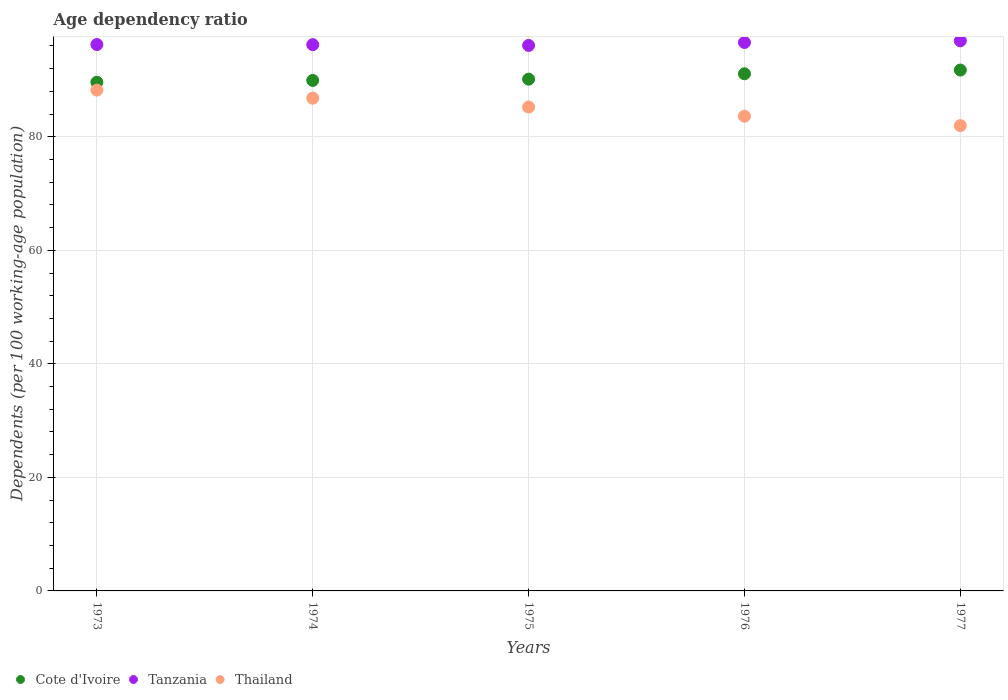How many different coloured dotlines are there?
Offer a very short reply. 3. Is the number of dotlines equal to the number of legend labels?
Your answer should be very brief. Yes. What is the age dependency ratio in in Tanzania in 1977?
Give a very brief answer. 96.91. Across all years, what is the maximum age dependency ratio in in Cote d'Ivoire?
Make the answer very short. 91.76. Across all years, what is the minimum age dependency ratio in in Tanzania?
Your answer should be very brief. 96.09. In which year was the age dependency ratio in in Tanzania minimum?
Offer a very short reply. 1975. What is the total age dependency ratio in in Thailand in the graph?
Your response must be concise. 425.87. What is the difference between the age dependency ratio in in Cote d'Ivoire in 1974 and that in 1976?
Make the answer very short. -1.17. What is the difference between the age dependency ratio in in Tanzania in 1973 and the age dependency ratio in in Cote d'Ivoire in 1975?
Your answer should be compact. 6.1. What is the average age dependency ratio in in Cote d'Ivoire per year?
Your response must be concise. 90.51. In the year 1974, what is the difference between the age dependency ratio in in Tanzania and age dependency ratio in in Thailand?
Your answer should be very brief. 9.42. In how many years, is the age dependency ratio in in Cote d'Ivoire greater than 28 %?
Your response must be concise. 5. What is the ratio of the age dependency ratio in in Tanzania in 1974 to that in 1976?
Your answer should be compact. 1. Is the age dependency ratio in in Thailand in 1975 less than that in 1976?
Provide a short and direct response. No. Is the difference between the age dependency ratio in in Tanzania in 1974 and 1976 greater than the difference between the age dependency ratio in in Thailand in 1974 and 1976?
Provide a short and direct response. No. What is the difference between the highest and the second highest age dependency ratio in in Thailand?
Give a very brief answer. 1.42. What is the difference between the highest and the lowest age dependency ratio in in Cote d'Ivoire?
Give a very brief answer. 2.14. Is the sum of the age dependency ratio in in Cote d'Ivoire in 1973 and 1977 greater than the maximum age dependency ratio in in Thailand across all years?
Offer a terse response. Yes. Does the age dependency ratio in in Thailand monotonically increase over the years?
Keep it short and to the point. No. How many dotlines are there?
Make the answer very short. 3. Where does the legend appear in the graph?
Offer a very short reply. Bottom left. How many legend labels are there?
Keep it short and to the point. 3. What is the title of the graph?
Ensure brevity in your answer.  Age dependency ratio. Does "Spain" appear as one of the legend labels in the graph?
Your response must be concise. No. What is the label or title of the Y-axis?
Your answer should be compact. Dependents (per 100 working-age population). What is the Dependents (per 100 working-age population) in Cote d'Ivoire in 1973?
Provide a succinct answer. 89.61. What is the Dependents (per 100 working-age population) in Tanzania in 1973?
Ensure brevity in your answer.  96.25. What is the Dependents (per 100 working-age population) of Thailand in 1973?
Keep it short and to the point. 88.22. What is the Dependents (per 100 working-age population) in Cote d'Ivoire in 1974?
Provide a succinct answer. 89.93. What is the Dependents (per 100 working-age population) of Tanzania in 1974?
Provide a succinct answer. 96.23. What is the Dependents (per 100 working-age population) of Thailand in 1974?
Your answer should be very brief. 86.81. What is the Dependents (per 100 working-age population) in Cote d'Ivoire in 1975?
Keep it short and to the point. 90.15. What is the Dependents (per 100 working-age population) in Tanzania in 1975?
Give a very brief answer. 96.09. What is the Dependents (per 100 working-age population) in Thailand in 1975?
Ensure brevity in your answer.  85.24. What is the Dependents (per 100 working-age population) of Cote d'Ivoire in 1976?
Your answer should be compact. 91.1. What is the Dependents (per 100 working-age population) in Tanzania in 1976?
Offer a terse response. 96.61. What is the Dependents (per 100 working-age population) in Thailand in 1976?
Provide a succinct answer. 83.62. What is the Dependents (per 100 working-age population) in Cote d'Ivoire in 1977?
Provide a short and direct response. 91.76. What is the Dependents (per 100 working-age population) of Tanzania in 1977?
Make the answer very short. 96.91. What is the Dependents (per 100 working-age population) in Thailand in 1977?
Make the answer very short. 81.97. Across all years, what is the maximum Dependents (per 100 working-age population) of Cote d'Ivoire?
Your response must be concise. 91.76. Across all years, what is the maximum Dependents (per 100 working-age population) of Tanzania?
Offer a very short reply. 96.91. Across all years, what is the maximum Dependents (per 100 working-age population) in Thailand?
Keep it short and to the point. 88.22. Across all years, what is the minimum Dependents (per 100 working-age population) of Cote d'Ivoire?
Make the answer very short. 89.61. Across all years, what is the minimum Dependents (per 100 working-age population) in Tanzania?
Keep it short and to the point. 96.09. Across all years, what is the minimum Dependents (per 100 working-age population) of Thailand?
Offer a very short reply. 81.97. What is the total Dependents (per 100 working-age population) of Cote d'Ivoire in the graph?
Ensure brevity in your answer.  452.55. What is the total Dependents (per 100 working-age population) of Tanzania in the graph?
Offer a terse response. 482.09. What is the total Dependents (per 100 working-age population) in Thailand in the graph?
Keep it short and to the point. 425.87. What is the difference between the Dependents (per 100 working-age population) in Cote d'Ivoire in 1973 and that in 1974?
Your answer should be very brief. -0.32. What is the difference between the Dependents (per 100 working-age population) in Tanzania in 1973 and that in 1974?
Offer a terse response. 0.02. What is the difference between the Dependents (per 100 working-age population) of Thailand in 1973 and that in 1974?
Ensure brevity in your answer.  1.42. What is the difference between the Dependents (per 100 working-age population) in Cote d'Ivoire in 1973 and that in 1975?
Your response must be concise. -0.54. What is the difference between the Dependents (per 100 working-age population) in Tanzania in 1973 and that in 1975?
Give a very brief answer. 0.16. What is the difference between the Dependents (per 100 working-age population) in Thailand in 1973 and that in 1975?
Keep it short and to the point. 2.98. What is the difference between the Dependents (per 100 working-age population) in Cote d'Ivoire in 1973 and that in 1976?
Your answer should be very brief. -1.49. What is the difference between the Dependents (per 100 working-age population) in Tanzania in 1973 and that in 1976?
Make the answer very short. -0.36. What is the difference between the Dependents (per 100 working-age population) in Thailand in 1973 and that in 1976?
Your answer should be very brief. 4.6. What is the difference between the Dependents (per 100 working-age population) of Cote d'Ivoire in 1973 and that in 1977?
Provide a short and direct response. -2.14. What is the difference between the Dependents (per 100 working-age population) of Tanzania in 1973 and that in 1977?
Provide a succinct answer. -0.66. What is the difference between the Dependents (per 100 working-age population) in Thailand in 1973 and that in 1977?
Give a very brief answer. 6.26. What is the difference between the Dependents (per 100 working-age population) in Cote d'Ivoire in 1974 and that in 1975?
Provide a short and direct response. -0.22. What is the difference between the Dependents (per 100 working-age population) of Tanzania in 1974 and that in 1975?
Offer a very short reply. 0.13. What is the difference between the Dependents (per 100 working-age population) in Thailand in 1974 and that in 1975?
Keep it short and to the point. 1.56. What is the difference between the Dependents (per 100 working-age population) in Cote d'Ivoire in 1974 and that in 1976?
Offer a very short reply. -1.17. What is the difference between the Dependents (per 100 working-age population) of Tanzania in 1974 and that in 1976?
Keep it short and to the point. -0.38. What is the difference between the Dependents (per 100 working-age population) of Thailand in 1974 and that in 1976?
Your response must be concise. 3.18. What is the difference between the Dependents (per 100 working-age population) of Cote d'Ivoire in 1974 and that in 1977?
Your answer should be compact. -1.83. What is the difference between the Dependents (per 100 working-age population) of Tanzania in 1974 and that in 1977?
Your response must be concise. -0.68. What is the difference between the Dependents (per 100 working-age population) of Thailand in 1974 and that in 1977?
Make the answer very short. 4.84. What is the difference between the Dependents (per 100 working-age population) of Cote d'Ivoire in 1975 and that in 1976?
Provide a short and direct response. -0.95. What is the difference between the Dependents (per 100 working-age population) in Tanzania in 1975 and that in 1976?
Provide a short and direct response. -0.52. What is the difference between the Dependents (per 100 working-age population) in Thailand in 1975 and that in 1976?
Make the answer very short. 1.62. What is the difference between the Dependents (per 100 working-age population) in Cote d'Ivoire in 1975 and that in 1977?
Your answer should be compact. -1.61. What is the difference between the Dependents (per 100 working-age population) of Tanzania in 1975 and that in 1977?
Provide a short and direct response. -0.81. What is the difference between the Dependents (per 100 working-age population) of Thailand in 1975 and that in 1977?
Provide a succinct answer. 3.28. What is the difference between the Dependents (per 100 working-age population) of Cote d'Ivoire in 1976 and that in 1977?
Give a very brief answer. -0.66. What is the difference between the Dependents (per 100 working-age population) of Tanzania in 1976 and that in 1977?
Your response must be concise. -0.3. What is the difference between the Dependents (per 100 working-age population) of Thailand in 1976 and that in 1977?
Ensure brevity in your answer.  1.66. What is the difference between the Dependents (per 100 working-age population) of Cote d'Ivoire in 1973 and the Dependents (per 100 working-age population) of Tanzania in 1974?
Offer a very short reply. -6.62. What is the difference between the Dependents (per 100 working-age population) of Cote d'Ivoire in 1973 and the Dependents (per 100 working-age population) of Thailand in 1974?
Ensure brevity in your answer.  2.81. What is the difference between the Dependents (per 100 working-age population) of Tanzania in 1973 and the Dependents (per 100 working-age population) of Thailand in 1974?
Offer a terse response. 9.45. What is the difference between the Dependents (per 100 working-age population) in Cote d'Ivoire in 1973 and the Dependents (per 100 working-age population) in Tanzania in 1975?
Your answer should be very brief. -6.48. What is the difference between the Dependents (per 100 working-age population) in Cote d'Ivoire in 1973 and the Dependents (per 100 working-age population) in Thailand in 1975?
Provide a succinct answer. 4.37. What is the difference between the Dependents (per 100 working-age population) in Tanzania in 1973 and the Dependents (per 100 working-age population) in Thailand in 1975?
Offer a terse response. 11.01. What is the difference between the Dependents (per 100 working-age population) of Cote d'Ivoire in 1973 and the Dependents (per 100 working-age population) of Tanzania in 1976?
Provide a succinct answer. -7. What is the difference between the Dependents (per 100 working-age population) of Cote d'Ivoire in 1973 and the Dependents (per 100 working-age population) of Thailand in 1976?
Make the answer very short. 5.99. What is the difference between the Dependents (per 100 working-age population) of Tanzania in 1973 and the Dependents (per 100 working-age population) of Thailand in 1976?
Your answer should be compact. 12.63. What is the difference between the Dependents (per 100 working-age population) in Cote d'Ivoire in 1973 and the Dependents (per 100 working-age population) in Tanzania in 1977?
Keep it short and to the point. -7.29. What is the difference between the Dependents (per 100 working-age population) in Cote d'Ivoire in 1973 and the Dependents (per 100 working-age population) in Thailand in 1977?
Your answer should be compact. 7.65. What is the difference between the Dependents (per 100 working-age population) in Tanzania in 1973 and the Dependents (per 100 working-age population) in Thailand in 1977?
Ensure brevity in your answer.  14.28. What is the difference between the Dependents (per 100 working-age population) of Cote d'Ivoire in 1974 and the Dependents (per 100 working-age population) of Tanzania in 1975?
Your answer should be very brief. -6.16. What is the difference between the Dependents (per 100 working-age population) in Cote d'Ivoire in 1974 and the Dependents (per 100 working-age population) in Thailand in 1975?
Ensure brevity in your answer.  4.69. What is the difference between the Dependents (per 100 working-age population) of Tanzania in 1974 and the Dependents (per 100 working-age population) of Thailand in 1975?
Provide a succinct answer. 10.99. What is the difference between the Dependents (per 100 working-age population) in Cote d'Ivoire in 1974 and the Dependents (per 100 working-age population) in Tanzania in 1976?
Provide a succinct answer. -6.68. What is the difference between the Dependents (per 100 working-age population) of Cote d'Ivoire in 1974 and the Dependents (per 100 working-age population) of Thailand in 1976?
Your response must be concise. 6.31. What is the difference between the Dependents (per 100 working-age population) of Tanzania in 1974 and the Dependents (per 100 working-age population) of Thailand in 1976?
Give a very brief answer. 12.6. What is the difference between the Dependents (per 100 working-age population) of Cote d'Ivoire in 1974 and the Dependents (per 100 working-age population) of Tanzania in 1977?
Ensure brevity in your answer.  -6.98. What is the difference between the Dependents (per 100 working-age population) of Cote d'Ivoire in 1974 and the Dependents (per 100 working-age population) of Thailand in 1977?
Your response must be concise. 7.96. What is the difference between the Dependents (per 100 working-age population) in Tanzania in 1974 and the Dependents (per 100 working-age population) in Thailand in 1977?
Offer a very short reply. 14.26. What is the difference between the Dependents (per 100 working-age population) in Cote d'Ivoire in 1975 and the Dependents (per 100 working-age population) in Tanzania in 1976?
Provide a short and direct response. -6.46. What is the difference between the Dependents (per 100 working-age population) of Cote d'Ivoire in 1975 and the Dependents (per 100 working-age population) of Thailand in 1976?
Keep it short and to the point. 6.53. What is the difference between the Dependents (per 100 working-age population) of Tanzania in 1975 and the Dependents (per 100 working-age population) of Thailand in 1976?
Give a very brief answer. 12.47. What is the difference between the Dependents (per 100 working-age population) of Cote d'Ivoire in 1975 and the Dependents (per 100 working-age population) of Tanzania in 1977?
Your response must be concise. -6.76. What is the difference between the Dependents (per 100 working-age population) of Cote d'Ivoire in 1975 and the Dependents (per 100 working-age population) of Thailand in 1977?
Ensure brevity in your answer.  8.18. What is the difference between the Dependents (per 100 working-age population) in Tanzania in 1975 and the Dependents (per 100 working-age population) in Thailand in 1977?
Offer a terse response. 14.13. What is the difference between the Dependents (per 100 working-age population) in Cote d'Ivoire in 1976 and the Dependents (per 100 working-age population) in Tanzania in 1977?
Your answer should be compact. -5.81. What is the difference between the Dependents (per 100 working-age population) of Cote d'Ivoire in 1976 and the Dependents (per 100 working-age population) of Thailand in 1977?
Make the answer very short. 9.13. What is the difference between the Dependents (per 100 working-age population) in Tanzania in 1976 and the Dependents (per 100 working-age population) in Thailand in 1977?
Your answer should be very brief. 14.65. What is the average Dependents (per 100 working-age population) in Cote d'Ivoire per year?
Provide a short and direct response. 90.51. What is the average Dependents (per 100 working-age population) of Tanzania per year?
Your response must be concise. 96.42. What is the average Dependents (per 100 working-age population) in Thailand per year?
Provide a succinct answer. 85.17. In the year 1973, what is the difference between the Dependents (per 100 working-age population) in Cote d'Ivoire and Dependents (per 100 working-age population) in Tanzania?
Offer a terse response. -6.64. In the year 1973, what is the difference between the Dependents (per 100 working-age population) in Cote d'Ivoire and Dependents (per 100 working-age population) in Thailand?
Offer a terse response. 1.39. In the year 1973, what is the difference between the Dependents (per 100 working-age population) of Tanzania and Dependents (per 100 working-age population) of Thailand?
Make the answer very short. 8.03. In the year 1974, what is the difference between the Dependents (per 100 working-age population) in Cote d'Ivoire and Dependents (per 100 working-age population) in Tanzania?
Offer a very short reply. -6.3. In the year 1974, what is the difference between the Dependents (per 100 working-age population) in Cote d'Ivoire and Dependents (per 100 working-age population) in Thailand?
Keep it short and to the point. 3.12. In the year 1974, what is the difference between the Dependents (per 100 working-age population) of Tanzania and Dependents (per 100 working-age population) of Thailand?
Ensure brevity in your answer.  9.42. In the year 1975, what is the difference between the Dependents (per 100 working-age population) of Cote d'Ivoire and Dependents (per 100 working-age population) of Tanzania?
Make the answer very short. -5.94. In the year 1975, what is the difference between the Dependents (per 100 working-age population) of Cote d'Ivoire and Dependents (per 100 working-age population) of Thailand?
Your answer should be very brief. 4.91. In the year 1975, what is the difference between the Dependents (per 100 working-age population) of Tanzania and Dependents (per 100 working-age population) of Thailand?
Ensure brevity in your answer.  10.85. In the year 1976, what is the difference between the Dependents (per 100 working-age population) in Cote d'Ivoire and Dependents (per 100 working-age population) in Tanzania?
Keep it short and to the point. -5.51. In the year 1976, what is the difference between the Dependents (per 100 working-age population) of Cote d'Ivoire and Dependents (per 100 working-age population) of Thailand?
Offer a terse response. 7.48. In the year 1976, what is the difference between the Dependents (per 100 working-age population) of Tanzania and Dependents (per 100 working-age population) of Thailand?
Your response must be concise. 12.99. In the year 1977, what is the difference between the Dependents (per 100 working-age population) in Cote d'Ivoire and Dependents (per 100 working-age population) in Tanzania?
Offer a terse response. -5.15. In the year 1977, what is the difference between the Dependents (per 100 working-age population) of Cote d'Ivoire and Dependents (per 100 working-age population) of Thailand?
Make the answer very short. 9.79. In the year 1977, what is the difference between the Dependents (per 100 working-age population) of Tanzania and Dependents (per 100 working-age population) of Thailand?
Offer a very short reply. 14.94. What is the ratio of the Dependents (per 100 working-age population) in Cote d'Ivoire in 1973 to that in 1974?
Offer a very short reply. 1. What is the ratio of the Dependents (per 100 working-age population) in Tanzania in 1973 to that in 1974?
Make the answer very short. 1. What is the ratio of the Dependents (per 100 working-age population) in Thailand in 1973 to that in 1974?
Offer a terse response. 1.02. What is the ratio of the Dependents (per 100 working-age population) in Tanzania in 1973 to that in 1975?
Your answer should be very brief. 1. What is the ratio of the Dependents (per 100 working-age population) of Thailand in 1973 to that in 1975?
Your answer should be compact. 1.03. What is the ratio of the Dependents (per 100 working-age population) in Cote d'Ivoire in 1973 to that in 1976?
Offer a terse response. 0.98. What is the ratio of the Dependents (per 100 working-age population) in Tanzania in 1973 to that in 1976?
Give a very brief answer. 1. What is the ratio of the Dependents (per 100 working-age population) in Thailand in 1973 to that in 1976?
Your answer should be compact. 1.05. What is the ratio of the Dependents (per 100 working-age population) in Cote d'Ivoire in 1973 to that in 1977?
Your answer should be very brief. 0.98. What is the ratio of the Dependents (per 100 working-age population) in Tanzania in 1973 to that in 1977?
Your response must be concise. 0.99. What is the ratio of the Dependents (per 100 working-age population) in Thailand in 1973 to that in 1977?
Provide a succinct answer. 1.08. What is the ratio of the Dependents (per 100 working-age population) in Cote d'Ivoire in 1974 to that in 1975?
Offer a terse response. 1. What is the ratio of the Dependents (per 100 working-age population) in Tanzania in 1974 to that in 1975?
Offer a very short reply. 1. What is the ratio of the Dependents (per 100 working-age population) of Thailand in 1974 to that in 1975?
Provide a succinct answer. 1.02. What is the ratio of the Dependents (per 100 working-age population) in Cote d'Ivoire in 1974 to that in 1976?
Make the answer very short. 0.99. What is the ratio of the Dependents (per 100 working-age population) of Tanzania in 1974 to that in 1976?
Provide a succinct answer. 1. What is the ratio of the Dependents (per 100 working-age population) of Thailand in 1974 to that in 1976?
Ensure brevity in your answer.  1.04. What is the ratio of the Dependents (per 100 working-age population) of Cote d'Ivoire in 1974 to that in 1977?
Offer a very short reply. 0.98. What is the ratio of the Dependents (per 100 working-age population) in Thailand in 1974 to that in 1977?
Offer a terse response. 1.06. What is the ratio of the Dependents (per 100 working-age population) of Tanzania in 1975 to that in 1976?
Keep it short and to the point. 0.99. What is the ratio of the Dependents (per 100 working-age population) in Thailand in 1975 to that in 1976?
Your response must be concise. 1.02. What is the ratio of the Dependents (per 100 working-age population) of Cote d'Ivoire in 1975 to that in 1977?
Ensure brevity in your answer.  0.98. What is the ratio of the Dependents (per 100 working-age population) of Tanzania in 1975 to that in 1977?
Your response must be concise. 0.99. What is the ratio of the Dependents (per 100 working-age population) in Thailand in 1975 to that in 1977?
Your answer should be compact. 1.04. What is the ratio of the Dependents (per 100 working-age population) in Tanzania in 1976 to that in 1977?
Your answer should be very brief. 1. What is the ratio of the Dependents (per 100 working-age population) of Thailand in 1976 to that in 1977?
Your answer should be very brief. 1.02. What is the difference between the highest and the second highest Dependents (per 100 working-age population) in Cote d'Ivoire?
Ensure brevity in your answer.  0.66. What is the difference between the highest and the second highest Dependents (per 100 working-age population) of Tanzania?
Your answer should be very brief. 0.3. What is the difference between the highest and the second highest Dependents (per 100 working-age population) of Thailand?
Give a very brief answer. 1.42. What is the difference between the highest and the lowest Dependents (per 100 working-age population) in Cote d'Ivoire?
Provide a short and direct response. 2.14. What is the difference between the highest and the lowest Dependents (per 100 working-age population) in Tanzania?
Offer a terse response. 0.81. What is the difference between the highest and the lowest Dependents (per 100 working-age population) in Thailand?
Offer a very short reply. 6.26. 